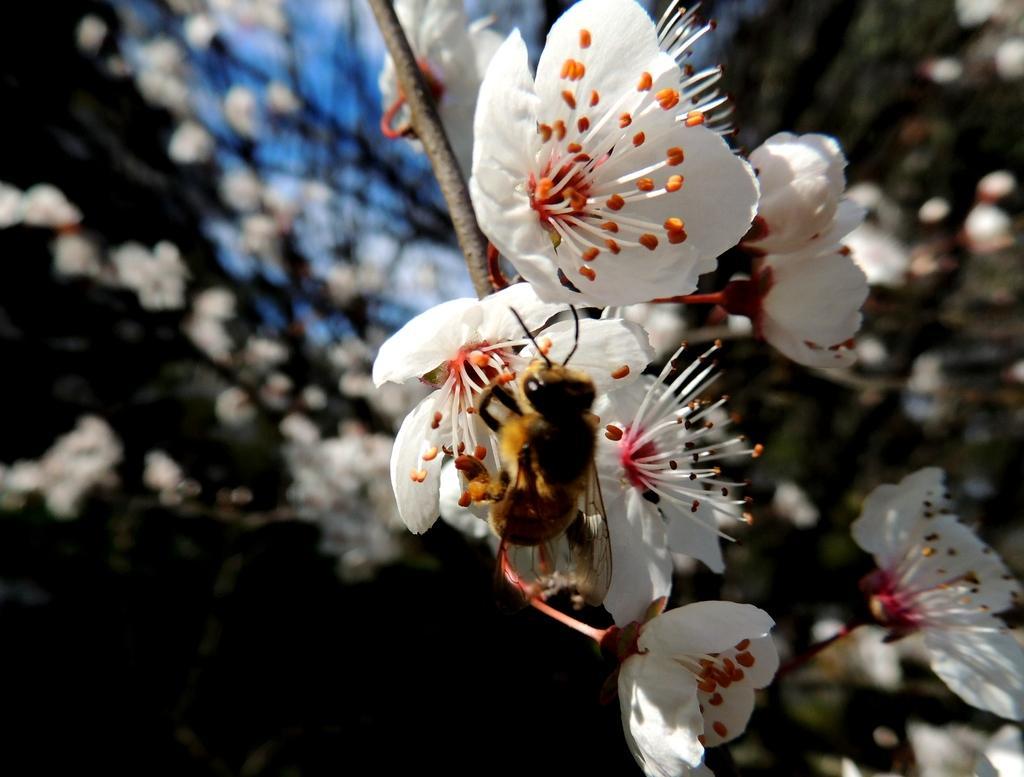Can you describe this image briefly? In this image, in the middle, we can see an insect which is on the flower and the flower is in white color. In the background, we can see some flowers and green color. 